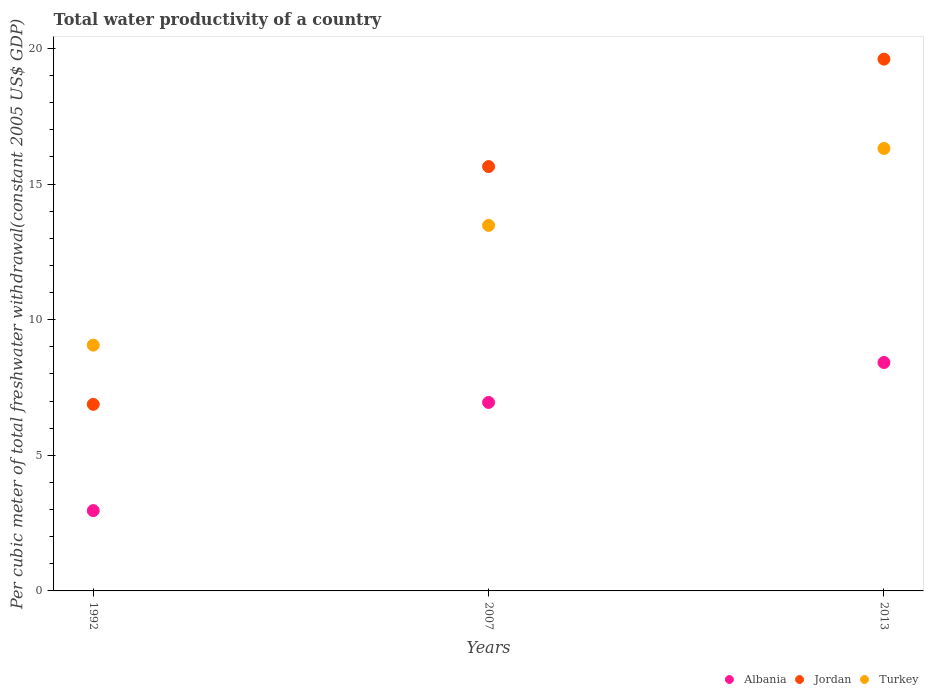What is the total water productivity in Turkey in 1992?
Your answer should be very brief. 9.06. Across all years, what is the maximum total water productivity in Turkey?
Your answer should be compact. 16.31. Across all years, what is the minimum total water productivity in Albania?
Your response must be concise. 2.96. What is the total total water productivity in Jordan in the graph?
Provide a short and direct response. 42.13. What is the difference between the total water productivity in Albania in 2007 and that in 2013?
Your response must be concise. -1.47. What is the difference between the total water productivity in Albania in 2013 and the total water productivity in Jordan in 2007?
Your response must be concise. -7.22. What is the average total water productivity in Albania per year?
Keep it short and to the point. 6.11. In the year 2007, what is the difference between the total water productivity in Albania and total water productivity in Jordan?
Your answer should be very brief. -8.7. What is the ratio of the total water productivity in Albania in 2007 to that in 2013?
Ensure brevity in your answer.  0.83. Is the total water productivity in Turkey in 1992 less than that in 2007?
Provide a succinct answer. Yes. Is the difference between the total water productivity in Albania in 2007 and 2013 greater than the difference between the total water productivity in Jordan in 2007 and 2013?
Ensure brevity in your answer.  Yes. What is the difference between the highest and the second highest total water productivity in Jordan?
Your answer should be very brief. 3.96. What is the difference between the highest and the lowest total water productivity in Jordan?
Provide a succinct answer. 12.73. In how many years, is the total water productivity in Jordan greater than the average total water productivity in Jordan taken over all years?
Ensure brevity in your answer.  2. How many years are there in the graph?
Your response must be concise. 3. Are the values on the major ticks of Y-axis written in scientific E-notation?
Provide a succinct answer. No. Where does the legend appear in the graph?
Offer a terse response. Bottom right. How many legend labels are there?
Make the answer very short. 3. How are the legend labels stacked?
Provide a succinct answer. Horizontal. What is the title of the graph?
Your answer should be compact. Total water productivity of a country. What is the label or title of the X-axis?
Make the answer very short. Years. What is the label or title of the Y-axis?
Make the answer very short. Per cubic meter of total freshwater withdrawal(constant 2005 US$ GDP). What is the Per cubic meter of total freshwater withdrawal(constant 2005 US$ GDP) of Albania in 1992?
Your answer should be compact. 2.96. What is the Per cubic meter of total freshwater withdrawal(constant 2005 US$ GDP) in Jordan in 1992?
Your answer should be compact. 6.88. What is the Per cubic meter of total freshwater withdrawal(constant 2005 US$ GDP) in Turkey in 1992?
Your answer should be compact. 9.06. What is the Per cubic meter of total freshwater withdrawal(constant 2005 US$ GDP) in Albania in 2007?
Make the answer very short. 6.95. What is the Per cubic meter of total freshwater withdrawal(constant 2005 US$ GDP) of Jordan in 2007?
Provide a succinct answer. 15.64. What is the Per cubic meter of total freshwater withdrawal(constant 2005 US$ GDP) of Turkey in 2007?
Provide a short and direct response. 13.48. What is the Per cubic meter of total freshwater withdrawal(constant 2005 US$ GDP) of Albania in 2013?
Your answer should be compact. 8.42. What is the Per cubic meter of total freshwater withdrawal(constant 2005 US$ GDP) of Jordan in 2013?
Offer a terse response. 19.6. What is the Per cubic meter of total freshwater withdrawal(constant 2005 US$ GDP) of Turkey in 2013?
Your response must be concise. 16.31. Across all years, what is the maximum Per cubic meter of total freshwater withdrawal(constant 2005 US$ GDP) in Albania?
Make the answer very short. 8.42. Across all years, what is the maximum Per cubic meter of total freshwater withdrawal(constant 2005 US$ GDP) of Jordan?
Ensure brevity in your answer.  19.6. Across all years, what is the maximum Per cubic meter of total freshwater withdrawal(constant 2005 US$ GDP) of Turkey?
Offer a terse response. 16.31. Across all years, what is the minimum Per cubic meter of total freshwater withdrawal(constant 2005 US$ GDP) in Albania?
Offer a very short reply. 2.96. Across all years, what is the minimum Per cubic meter of total freshwater withdrawal(constant 2005 US$ GDP) of Jordan?
Give a very brief answer. 6.88. Across all years, what is the minimum Per cubic meter of total freshwater withdrawal(constant 2005 US$ GDP) of Turkey?
Make the answer very short. 9.06. What is the total Per cubic meter of total freshwater withdrawal(constant 2005 US$ GDP) of Albania in the graph?
Your answer should be compact. 18.33. What is the total Per cubic meter of total freshwater withdrawal(constant 2005 US$ GDP) in Jordan in the graph?
Give a very brief answer. 42.13. What is the total Per cubic meter of total freshwater withdrawal(constant 2005 US$ GDP) of Turkey in the graph?
Ensure brevity in your answer.  38.85. What is the difference between the Per cubic meter of total freshwater withdrawal(constant 2005 US$ GDP) of Albania in 1992 and that in 2007?
Provide a succinct answer. -3.99. What is the difference between the Per cubic meter of total freshwater withdrawal(constant 2005 US$ GDP) of Jordan in 1992 and that in 2007?
Offer a terse response. -8.77. What is the difference between the Per cubic meter of total freshwater withdrawal(constant 2005 US$ GDP) in Turkey in 1992 and that in 2007?
Give a very brief answer. -4.41. What is the difference between the Per cubic meter of total freshwater withdrawal(constant 2005 US$ GDP) of Albania in 1992 and that in 2013?
Keep it short and to the point. -5.46. What is the difference between the Per cubic meter of total freshwater withdrawal(constant 2005 US$ GDP) in Jordan in 1992 and that in 2013?
Provide a short and direct response. -12.73. What is the difference between the Per cubic meter of total freshwater withdrawal(constant 2005 US$ GDP) in Turkey in 1992 and that in 2013?
Offer a very short reply. -7.25. What is the difference between the Per cubic meter of total freshwater withdrawal(constant 2005 US$ GDP) of Albania in 2007 and that in 2013?
Your answer should be very brief. -1.47. What is the difference between the Per cubic meter of total freshwater withdrawal(constant 2005 US$ GDP) in Jordan in 2007 and that in 2013?
Offer a terse response. -3.96. What is the difference between the Per cubic meter of total freshwater withdrawal(constant 2005 US$ GDP) of Turkey in 2007 and that in 2013?
Your response must be concise. -2.83. What is the difference between the Per cubic meter of total freshwater withdrawal(constant 2005 US$ GDP) of Albania in 1992 and the Per cubic meter of total freshwater withdrawal(constant 2005 US$ GDP) of Jordan in 2007?
Your answer should be very brief. -12.68. What is the difference between the Per cubic meter of total freshwater withdrawal(constant 2005 US$ GDP) in Albania in 1992 and the Per cubic meter of total freshwater withdrawal(constant 2005 US$ GDP) in Turkey in 2007?
Your answer should be compact. -10.51. What is the difference between the Per cubic meter of total freshwater withdrawal(constant 2005 US$ GDP) in Jordan in 1992 and the Per cubic meter of total freshwater withdrawal(constant 2005 US$ GDP) in Turkey in 2007?
Keep it short and to the point. -6.6. What is the difference between the Per cubic meter of total freshwater withdrawal(constant 2005 US$ GDP) in Albania in 1992 and the Per cubic meter of total freshwater withdrawal(constant 2005 US$ GDP) in Jordan in 2013?
Your answer should be compact. -16.64. What is the difference between the Per cubic meter of total freshwater withdrawal(constant 2005 US$ GDP) in Albania in 1992 and the Per cubic meter of total freshwater withdrawal(constant 2005 US$ GDP) in Turkey in 2013?
Give a very brief answer. -13.35. What is the difference between the Per cubic meter of total freshwater withdrawal(constant 2005 US$ GDP) in Jordan in 1992 and the Per cubic meter of total freshwater withdrawal(constant 2005 US$ GDP) in Turkey in 2013?
Keep it short and to the point. -9.43. What is the difference between the Per cubic meter of total freshwater withdrawal(constant 2005 US$ GDP) in Albania in 2007 and the Per cubic meter of total freshwater withdrawal(constant 2005 US$ GDP) in Jordan in 2013?
Your answer should be very brief. -12.66. What is the difference between the Per cubic meter of total freshwater withdrawal(constant 2005 US$ GDP) in Albania in 2007 and the Per cubic meter of total freshwater withdrawal(constant 2005 US$ GDP) in Turkey in 2013?
Your response must be concise. -9.36. What is the difference between the Per cubic meter of total freshwater withdrawal(constant 2005 US$ GDP) of Jordan in 2007 and the Per cubic meter of total freshwater withdrawal(constant 2005 US$ GDP) of Turkey in 2013?
Provide a succinct answer. -0.67. What is the average Per cubic meter of total freshwater withdrawal(constant 2005 US$ GDP) in Albania per year?
Give a very brief answer. 6.11. What is the average Per cubic meter of total freshwater withdrawal(constant 2005 US$ GDP) of Jordan per year?
Offer a very short reply. 14.04. What is the average Per cubic meter of total freshwater withdrawal(constant 2005 US$ GDP) of Turkey per year?
Offer a very short reply. 12.95. In the year 1992, what is the difference between the Per cubic meter of total freshwater withdrawal(constant 2005 US$ GDP) of Albania and Per cubic meter of total freshwater withdrawal(constant 2005 US$ GDP) of Jordan?
Offer a very short reply. -3.92. In the year 1992, what is the difference between the Per cubic meter of total freshwater withdrawal(constant 2005 US$ GDP) in Albania and Per cubic meter of total freshwater withdrawal(constant 2005 US$ GDP) in Turkey?
Your answer should be compact. -6.1. In the year 1992, what is the difference between the Per cubic meter of total freshwater withdrawal(constant 2005 US$ GDP) in Jordan and Per cubic meter of total freshwater withdrawal(constant 2005 US$ GDP) in Turkey?
Provide a short and direct response. -2.18. In the year 2007, what is the difference between the Per cubic meter of total freshwater withdrawal(constant 2005 US$ GDP) in Albania and Per cubic meter of total freshwater withdrawal(constant 2005 US$ GDP) in Jordan?
Your answer should be compact. -8.7. In the year 2007, what is the difference between the Per cubic meter of total freshwater withdrawal(constant 2005 US$ GDP) of Albania and Per cubic meter of total freshwater withdrawal(constant 2005 US$ GDP) of Turkey?
Offer a very short reply. -6.53. In the year 2007, what is the difference between the Per cubic meter of total freshwater withdrawal(constant 2005 US$ GDP) of Jordan and Per cubic meter of total freshwater withdrawal(constant 2005 US$ GDP) of Turkey?
Give a very brief answer. 2.17. In the year 2013, what is the difference between the Per cubic meter of total freshwater withdrawal(constant 2005 US$ GDP) in Albania and Per cubic meter of total freshwater withdrawal(constant 2005 US$ GDP) in Jordan?
Keep it short and to the point. -11.18. In the year 2013, what is the difference between the Per cubic meter of total freshwater withdrawal(constant 2005 US$ GDP) of Albania and Per cubic meter of total freshwater withdrawal(constant 2005 US$ GDP) of Turkey?
Offer a very short reply. -7.89. In the year 2013, what is the difference between the Per cubic meter of total freshwater withdrawal(constant 2005 US$ GDP) of Jordan and Per cubic meter of total freshwater withdrawal(constant 2005 US$ GDP) of Turkey?
Your response must be concise. 3.29. What is the ratio of the Per cubic meter of total freshwater withdrawal(constant 2005 US$ GDP) of Albania in 1992 to that in 2007?
Make the answer very short. 0.43. What is the ratio of the Per cubic meter of total freshwater withdrawal(constant 2005 US$ GDP) of Jordan in 1992 to that in 2007?
Your answer should be very brief. 0.44. What is the ratio of the Per cubic meter of total freshwater withdrawal(constant 2005 US$ GDP) in Turkey in 1992 to that in 2007?
Provide a short and direct response. 0.67. What is the ratio of the Per cubic meter of total freshwater withdrawal(constant 2005 US$ GDP) in Albania in 1992 to that in 2013?
Ensure brevity in your answer.  0.35. What is the ratio of the Per cubic meter of total freshwater withdrawal(constant 2005 US$ GDP) in Jordan in 1992 to that in 2013?
Your answer should be very brief. 0.35. What is the ratio of the Per cubic meter of total freshwater withdrawal(constant 2005 US$ GDP) of Turkey in 1992 to that in 2013?
Give a very brief answer. 0.56. What is the ratio of the Per cubic meter of total freshwater withdrawal(constant 2005 US$ GDP) of Albania in 2007 to that in 2013?
Your answer should be very brief. 0.83. What is the ratio of the Per cubic meter of total freshwater withdrawal(constant 2005 US$ GDP) in Jordan in 2007 to that in 2013?
Provide a short and direct response. 0.8. What is the ratio of the Per cubic meter of total freshwater withdrawal(constant 2005 US$ GDP) in Turkey in 2007 to that in 2013?
Make the answer very short. 0.83. What is the difference between the highest and the second highest Per cubic meter of total freshwater withdrawal(constant 2005 US$ GDP) in Albania?
Make the answer very short. 1.47. What is the difference between the highest and the second highest Per cubic meter of total freshwater withdrawal(constant 2005 US$ GDP) of Jordan?
Offer a very short reply. 3.96. What is the difference between the highest and the second highest Per cubic meter of total freshwater withdrawal(constant 2005 US$ GDP) in Turkey?
Provide a succinct answer. 2.83. What is the difference between the highest and the lowest Per cubic meter of total freshwater withdrawal(constant 2005 US$ GDP) in Albania?
Your answer should be very brief. 5.46. What is the difference between the highest and the lowest Per cubic meter of total freshwater withdrawal(constant 2005 US$ GDP) in Jordan?
Ensure brevity in your answer.  12.73. What is the difference between the highest and the lowest Per cubic meter of total freshwater withdrawal(constant 2005 US$ GDP) in Turkey?
Your response must be concise. 7.25. 